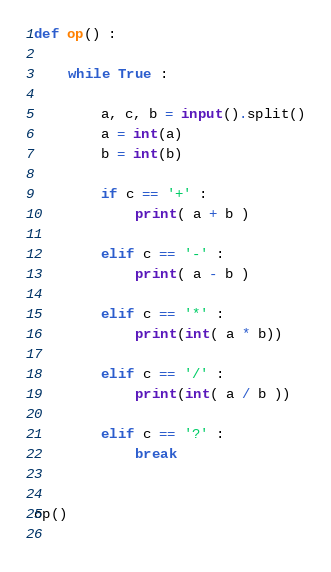<code> <loc_0><loc_0><loc_500><loc_500><_Python_>def op() :
    
    while True :
        
        a, c, b = input().split()
        a = int(a)
        b = int(b)
        
        if c == '+' :
            print( a + b )
       
        elif c == '-' :
            print( a - b )
        
        elif c == '*' :
            print(int( a * b))
        
        elif c == '/' :
            print(int( a / b ))
        
        elif c == '?' :
            break
        
        
op()
         
</code> 